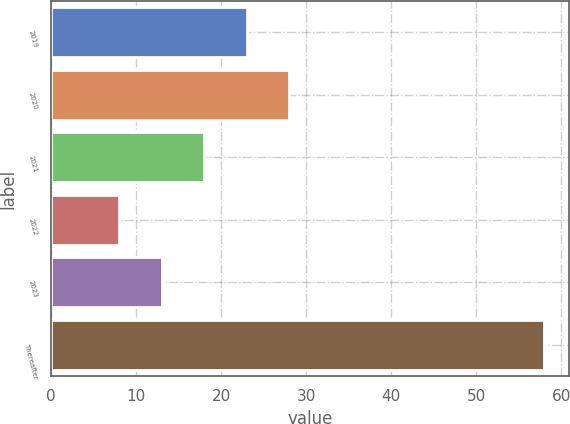Convert chart. <chart><loc_0><loc_0><loc_500><loc_500><bar_chart><fcel>2019<fcel>2020<fcel>2021<fcel>2022<fcel>2023<fcel>Thereafter<nl><fcel>23<fcel>28<fcel>18<fcel>8<fcel>13<fcel>58<nl></chart> 